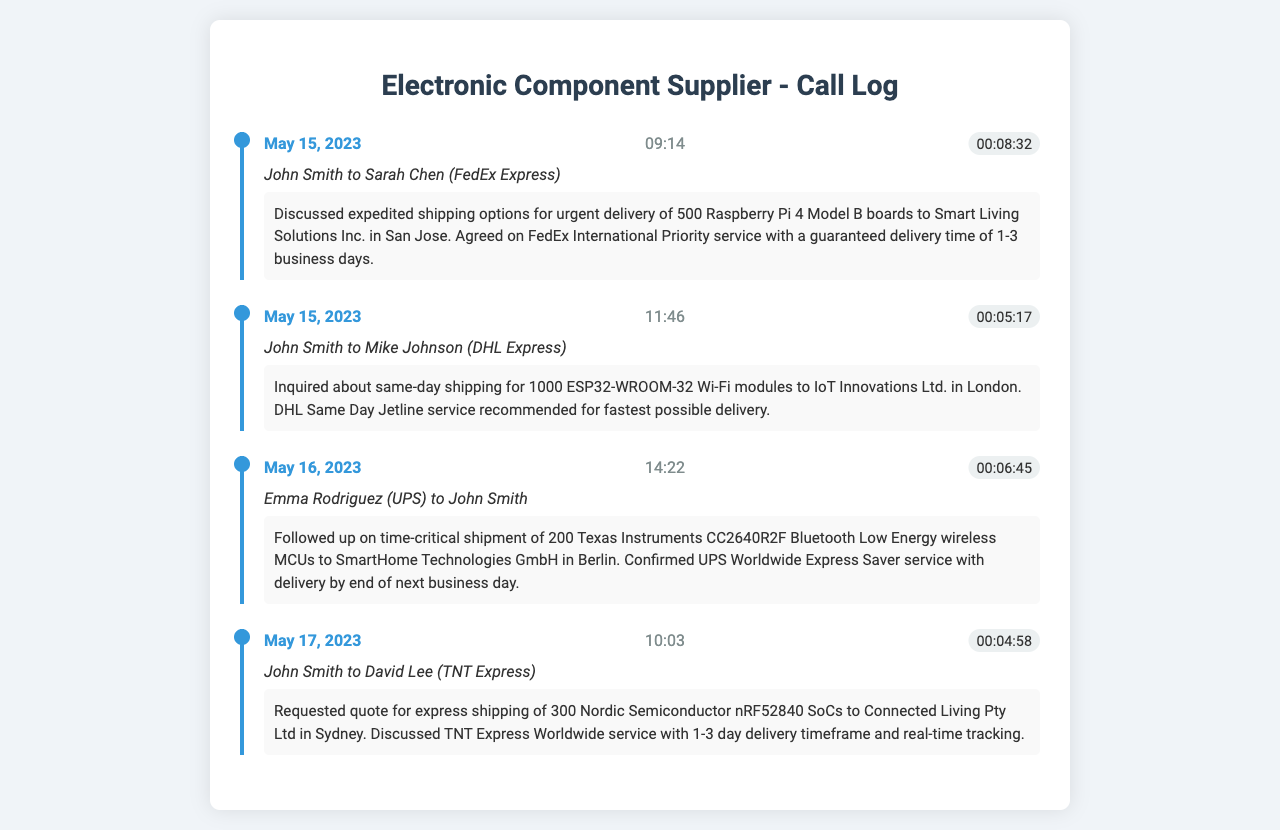what is the total number of Raspberry Pi boards discussed in the first call? The first call discusses the urgent delivery of 500 Raspberry Pi 4 Model B boards.
Answer: 500 what shipping service was agreed upon for the Raspberry Pi delivery? The call confirmed the use of FedEx International Priority service for delivery.
Answer: FedEx International Priority what is the delivery timeframe for the 1000 ESP32-WROOM-32 modules? The delivery timeframe for the modules is best served by the DHL Same Day Jetline service, which guarantees same-day shipping.
Answer: same-day shipping who followed up on the shipment of the Bluetooth MCUs? Emma Rodriguez from UPS followed up on the shipment.
Answer: Emma Rodriguez how many Texas Instruments CC2640R2F wireless MCUs were mentioned in the third call? The third call involves a time-critical shipment of 200 Texas Instruments CC2640R2F wireless MCUs.
Answer: 200 what was the date of the call regarding the TNT Express? The call regarding TNT Express occurred on May 17, 2023.
Answer: May 17, 2023 which company was the recipient of the 300 Nordic Semiconductor SoCs? The recipient company for the 300 Nordic Semiconductor nRF52840 SoCs is Connected Living Pty Ltd.
Answer: Connected Living Pty Ltd what service was confirmed for the UPS delivery to Berlin? The service confirmed for UPS delivery to Berlin was Worldwide Express Saver.
Answer: Worldwide Express Saver how long is the delivery timeframe for the TNT Express service discussed? The TNT Express service discussed has a delivery timeframe of 1-3 days.
Answer: 1-3 days 